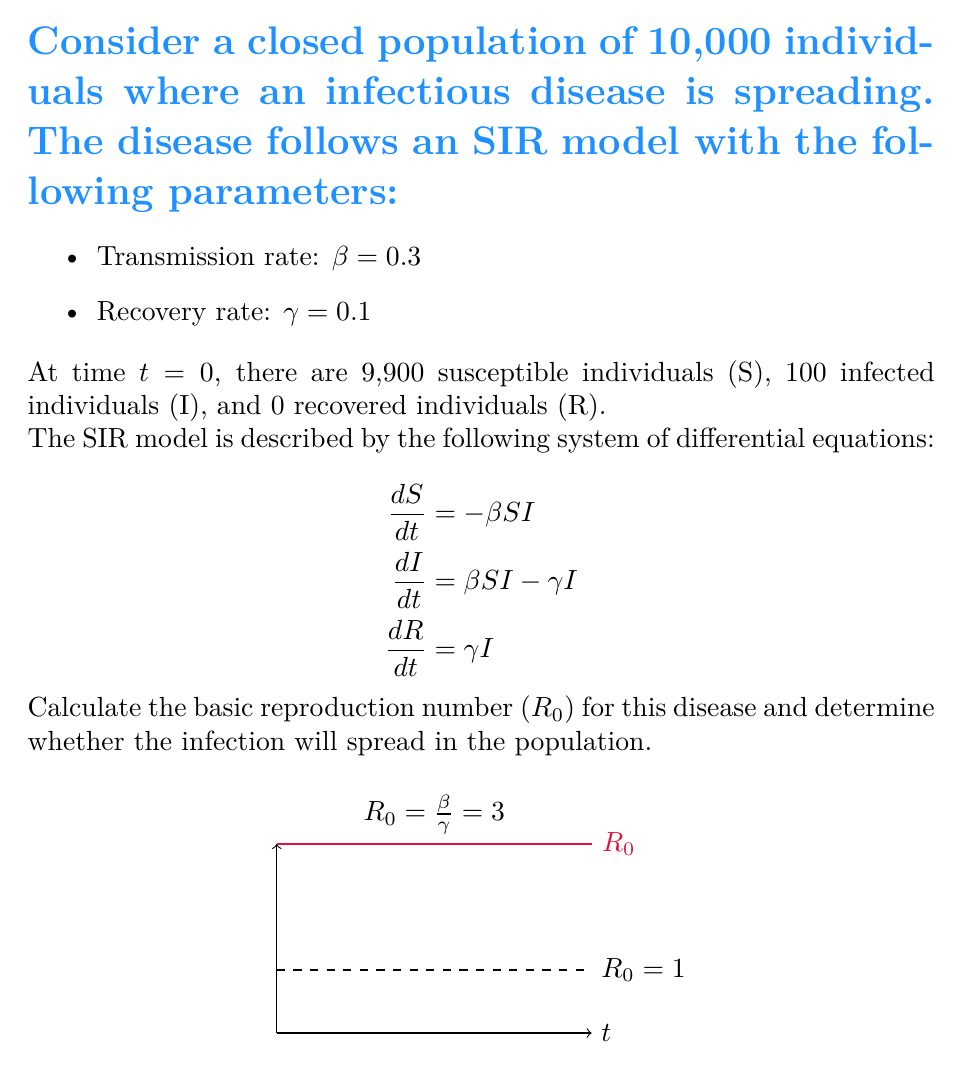Show me your answer to this math problem. To solve this problem, we'll follow these steps:

1) The basic reproduction number ($R_0$) is defined as the average number of secondary infections caused by a single infected individual in a completely susceptible population. In the SIR model, $R_0$ is calculated as:

   $$R_0 = \frac{\beta}{\gamma}$$

   Where $\beta$ is the transmission rate and $\gamma$ is the recovery rate.

2) Given:
   $\beta = 0.3$
   $\gamma = 0.1$

3) Substituting these values into the formula:

   $$R_0 = \frac{0.3}{0.1} = 3$$

4) Interpretation of $R_0$:
   - If $R_0 > 1$, the infection will spread in the population.
   - If $R_0 = 1$, the infection will stay steady in the population.
   - If $R_0 < 1$, the infection will die out in the population.

5) In this case, $R_0 = 3 > 1$, which means the infection will spread in the population.

The graph in the question visually represents this result, showing the $R_0$ value (red line) above the threshold of $R_0 = 1$ (dashed line).
Answer: $R_0 = 3$; The infection will spread. 